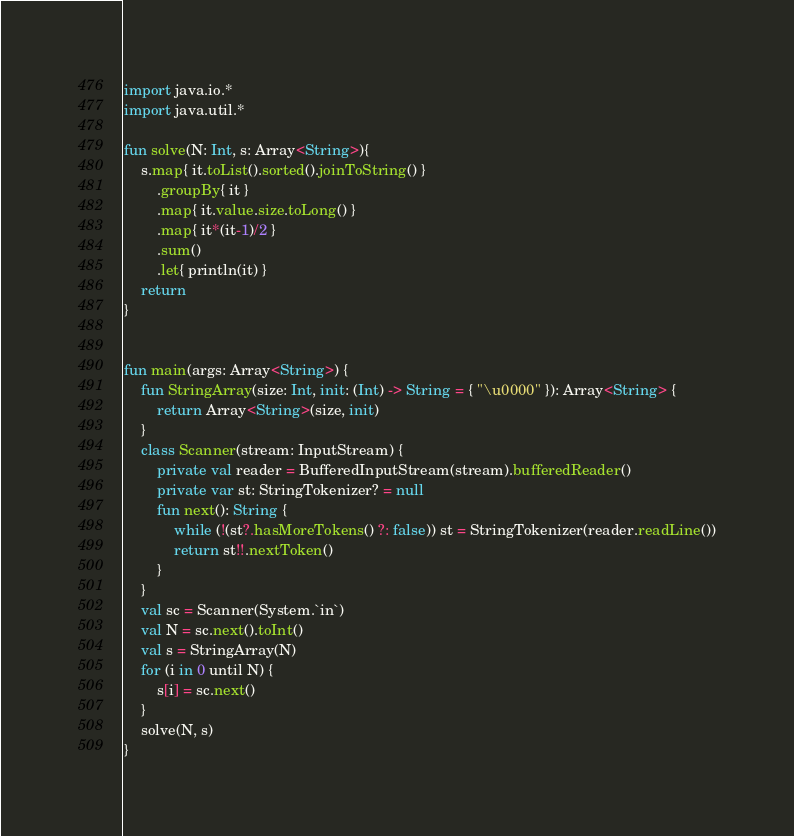Convert code to text. <code><loc_0><loc_0><loc_500><loc_500><_Kotlin_>import java.io.*
import java.util.*

fun solve(N: Int, s: Array<String>){
    s.map{ it.toList().sorted().joinToString() }
        .groupBy{ it }
        .map{ it.value.size.toLong() }
        .map{ it*(it-1)/2 }
        .sum()
        .let{ println(it) }
    return
}


fun main(args: Array<String>) {
    fun StringArray(size: Int, init: (Int) -> String = { "\u0000" }): Array<String> {
        return Array<String>(size, init)
    }
    class Scanner(stream: InputStream) {
        private val reader = BufferedInputStream(stream).bufferedReader()
        private var st: StringTokenizer? = null
        fun next(): String {
            while (!(st?.hasMoreTokens() ?: false)) st = StringTokenizer(reader.readLine())
            return st!!.nextToken()
        }
    }
    val sc = Scanner(System.`in`)
    val N = sc.next().toInt()
    val s = StringArray(N)
    for (i in 0 until N) {
        s[i] = sc.next()
    }
    solve(N, s)
}

</code> 